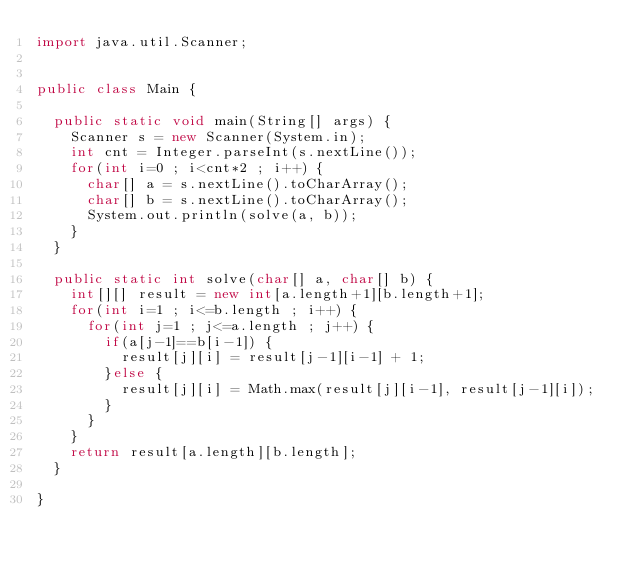<code> <loc_0><loc_0><loc_500><loc_500><_Java_>import java.util.Scanner;


public class Main {

	public static void main(String[] args) {
		Scanner s = new Scanner(System.in);
		int cnt = Integer.parseInt(s.nextLine());
		for(int i=0 ; i<cnt*2 ; i++) {
			char[] a = s.nextLine().toCharArray();
			char[] b = s.nextLine().toCharArray();
			System.out.println(solve(a, b));
		}
	}

	public static int solve(char[] a, char[] b) {
		int[][] result = new int[a.length+1][b.length+1];
		for(int i=1 ; i<=b.length ; i++) {
			for(int j=1 ; j<=a.length ; j++) {
				if(a[j-1]==b[i-1]) {
					result[j][i] = result[j-1][i-1] + 1;
				}else {
					result[j][i] = Math.max(result[j][i-1], result[j-1][i]);
				}
			}
		}
		return result[a.length][b.length];
	}

}</code> 